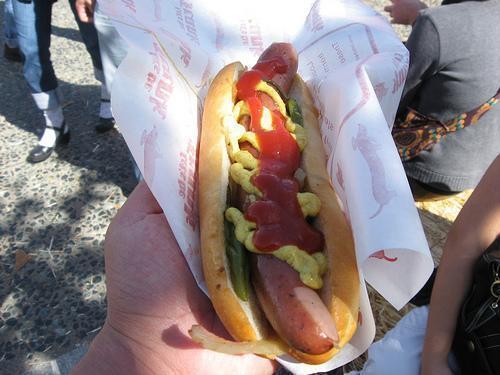Which ingredient contains the highest amount of sodium?
Choose the correct response, then elucidate: 'Answer: answer
Rationale: rationale.'
Options: Cucumber, ketchup, sausage, mustard. Answer: sausage.
Rationale: The ingredient is sausage. 